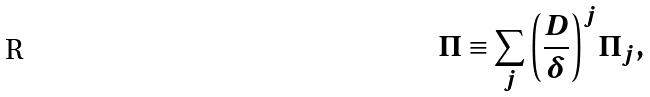Convert formula to latex. <formula><loc_0><loc_0><loc_500><loc_500>\Pi \equiv \sum _ { j } { \left ( \frac { D } { \delta } \right ) } ^ { j } { \Pi } _ { j } ,</formula> 